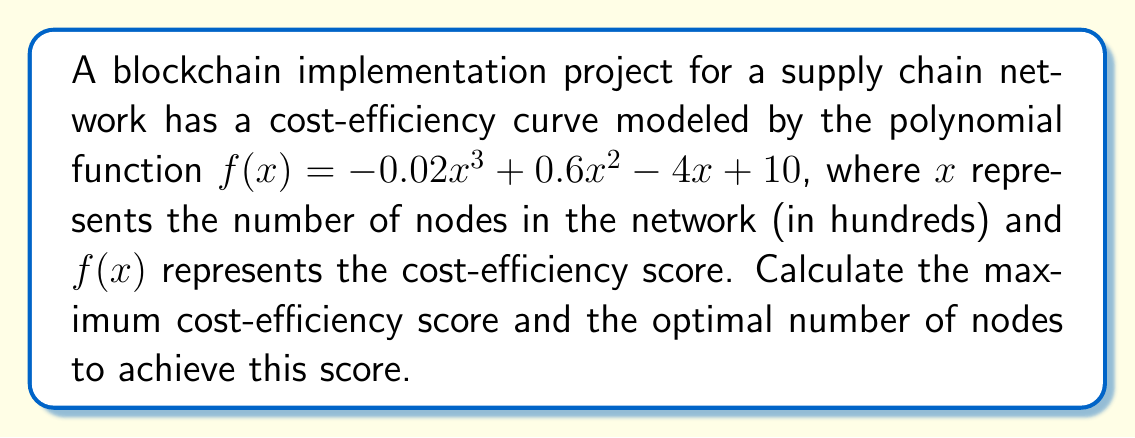Provide a solution to this math problem. To find the maximum cost-efficiency score and the optimal number of nodes, we need to follow these steps:

1. Find the derivative of the function:
   $f'(x) = -0.06x^2 + 1.2x - 4$

2. Set the derivative equal to zero to find critical points:
   $-0.06x^2 + 1.2x - 4 = 0$

3. Solve the quadratic equation:
   $-0.06(x^2 - 20x + 66.67) = 0$
   $(x - 10)^2 = 33.33$
   $x = 10 \pm \sqrt{33.33}$

   $x_1 \approx 15.77$ and $x_2 \approx 4.23$

4. Check the second derivative to confirm maximum:
   $f''(x) = -0.12x + 1.2$
   At $x = 15.77$: $f''(15.77) \approx -0.69 < 0$, confirming a maximum.

5. Calculate the maximum cost-efficiency score:
   $f(15.77) = -0.02(15.77)^3 + 0.6(15.77)^2 - 4(15.77) + 10 \approx 12.08$

6. Convert the optimal number of nodes back to hundreds:
   $15.77 \times 100 \approx 1,577$ nodes
Answer: Maximum cost-efficiency score: 12.08; Optimal number of nodes: 1,577 